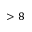Convert formula to latex. <formula><loc_0><loc_0><loc_500><loc_500>> 8</formula> 